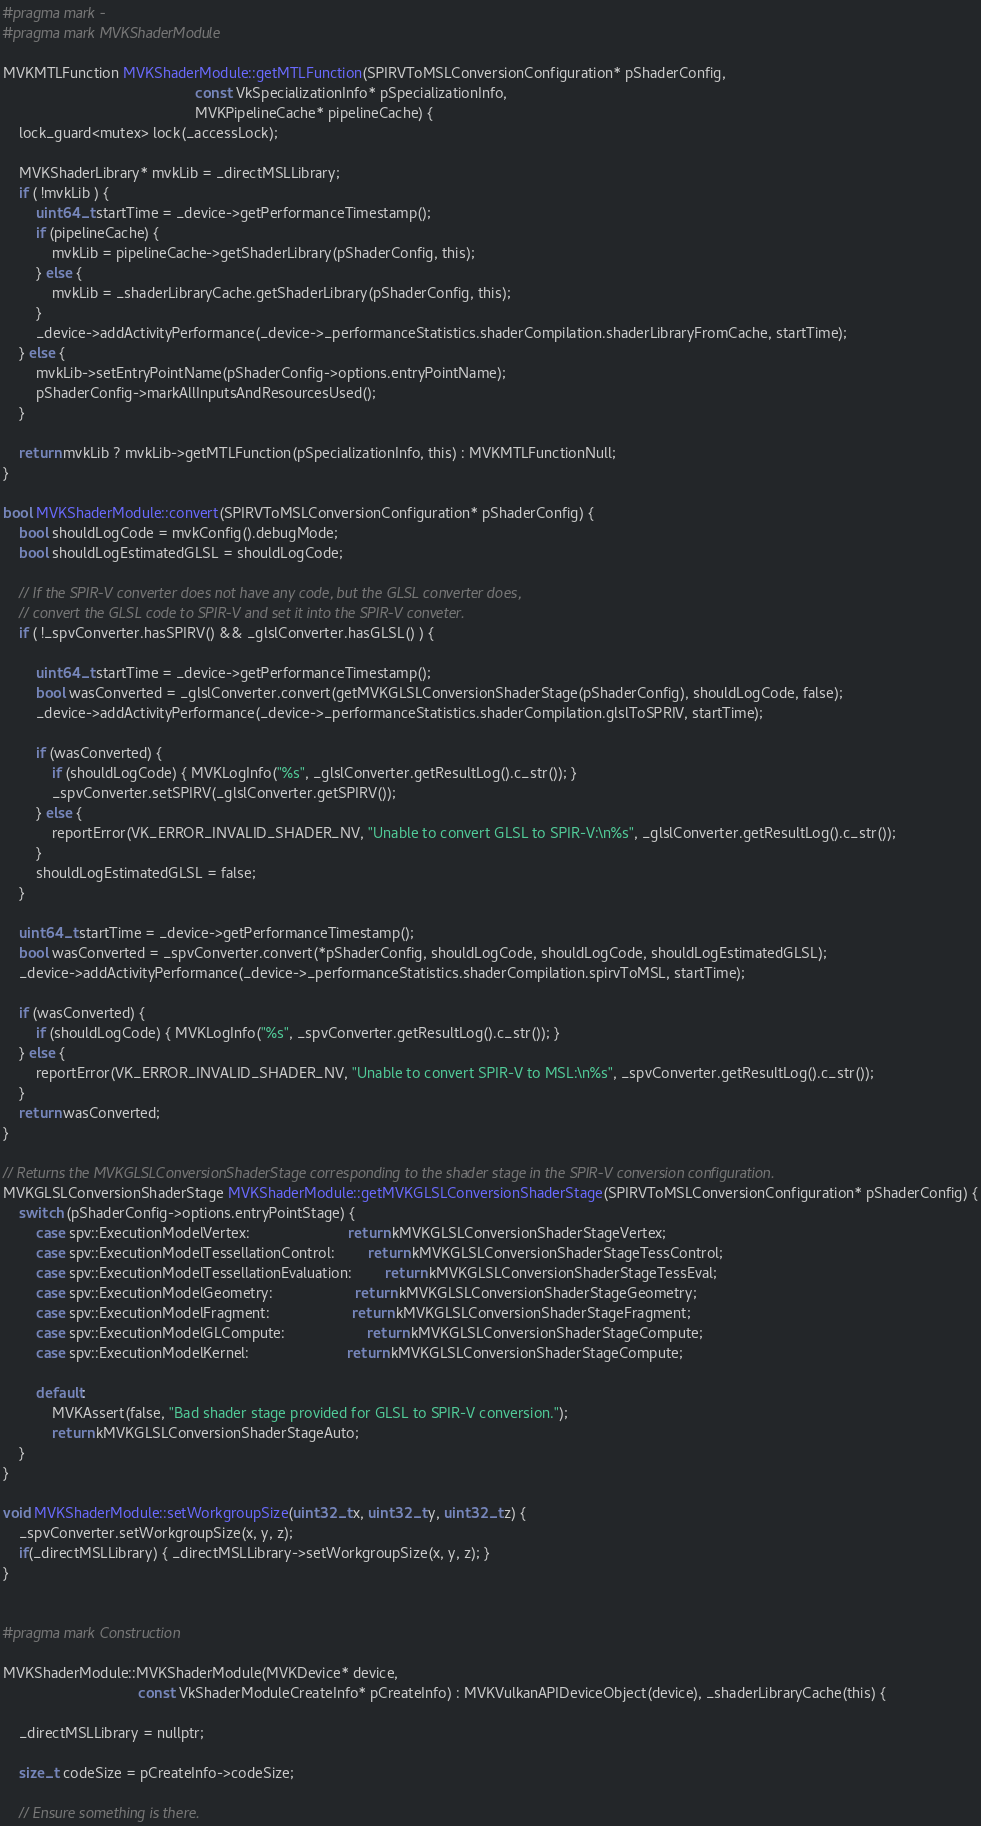<code> <loc_0><loc_0><loc_500><loc_500><_ObjectiveC_>

#pragma mark -
#pragma mark MVKShaderModule

MVKMTLFunction MVKShaderModule::getMTLFunction(SPIRVToMSLConversionConfiguration* pShaderConfig,
											   const VkSpecializationInfo* pSpecializationInfo,
											   MVKPipelineCache* pipelineCache) {
	lock_guard<mutex> lock(_accessLock);
	
	MVKShaderLibrary* mvkLib = _directMSLLibrary;
	if ( !mvkLib ) {
		uint64_t startTime = _device->getPerformanceTimestamp();
		if (pipelineCache) {
			mvkLib = pipelineCache->getShaderLibrary(pShaderConfig, this);
		} else {
			mvkLib = _shaderLibraryCache.getShaderLibrary(pShaderConfig, this);
		}
		_device->addActivityPerformance(_device->_performanceStatistics.shaderCompilation.shaderLibraryFromCache, startTime);
	} else {
		mvkLib->setEntryPointName(pShaderConfig->options.entryPointName);
		pShaderConfig->markAllInputsAndResourcesUsed();
	}

	return mvkLib ? mvkLib->getMTLFunction(pSpecializationInfo, this) : MVKMTLFunctionNull;
}

bool MVKShaderModule::convert(SPIRVToMSLConversionConfiguration* pShaderConfig) {
	bool shouldLogCode = mvkConfig().debugMode;
	bool shouldLogEstimatedGLSL = shouldLogCode;

	// If the SPIR-V converter does not have any code, but the GLSL converter does,
	// convert the GLSL code to SPIR-V and set it into the SPIR-V conveter.
	if ( !_spvConverter.hasSPIRV() && _glslConverter.hasGLSL() ) {

		uint64_t startTime = _device->getPerformanceTimestamp();
		bool wasConverted = _glslConverter.convert(getMVKGLSLConversionShaderStage(pShaderConfig), shouldLogCode, false);
		_device->addActivityPerformance(_device->_performanceStatistics.shaderCompilation.glslToSPRIV, startTime);

		if (wasConverted) {
			if (shouldLogCode) { MVKLogInfo("%s", _glslConverter.getResultLog().c_str()); }
			_spvConverter.setSPIRV(_glslConverter.getSPIRV());
		} else {
			reportError(VK_ERROR_INVALID_SHADER_NV, "Unable to convert GLSL to SPIR-V:\n%s", _glslConverter.getResultLog().c_str());
		}
		shouldLogEstimatedGLSL = false;
	}

	uint64_t startTime = _device->getPerformanceTimestamp();
	bool wasConverted = _spvConverter.convert(*pShaderConfig, shouldLogCode, shouldLogCode, shouldLogEstimatedGLSL);
	_device->addActivityPerformance(_device->_performanceStatistics.shaderCompilation.spirvToMSL, startTime);

	if (wasConverted) {
		if (shouldLogCode) { MVKLogInfo("%s", _spvConverter.getResultLog().c_str()); }
	} else {
		reportError(VK_ERROR_INVALID_SHADER_NV, "Unable to convert SPIR-V to MSL:\n%s", _spvConverter.getResultLog().c_str());
	}
	return wasConverted;
}

// Returns the MVKGLSLConversionShaderStage corresponding to the shader stage in the SPIR-V conversion configuration.
MVKGLSLConversionShaderStage MVKShaderModule::getMVKGLSLConversionShaderStage(SPIRVToMSLConversionConfiguration* pShaderConfig) {
	switch (pShaderConfig->options.entryPointStage) {
		case spv::ExecutionModelVertex:						return kMVKGLSLConversionShaderStageVertex;
		case spv::ExecutionModelTessellationControl:		return kMVKGLSLConversionShaderStageTessControl;
		case spv::ExecutionModelTessellationEvaluation:		return kMVKGLSLConversionShaderStageTessEval;
		case spv::ExecutionModelGeometry:					return kMVKGLSLConversionShaderStageGeometry;
		case spv::ExecutionModelFragment:					return kMVKGLSLConversionShaderStageFragment;
		case spv::ExecutionModelGLCompute:					return kMVKGLSLConversionShaderStageCompute;
		case spv::ExecutionModelKernel:						return kMVKGLSLConversionShaderStageCompute;

		default:
			MVKAssert(false, "Bad shader stage provided for GLSL to SPIR-V conversion.");
			return kMVKGLSLConversionShaderStageAuto;
	}
}

void MVKShaderModule::setWorkgroupSize(uint32_t x, uint32_t y, uint32_t z) {
	_spvConverter.setWorkgroupSize(x, y, z);
	if(_directMSLLibrary) { _directMSLLibrary->setWorkgroupSize(x, y, z); }
}


#pragma mark Construction

MVKShaderModule::MVKShaderModule(MVKDevice* device,
								 const VkShaderModuleCreateInfo* pCreateInfo) : MVKVulkanAPIDeviceObject(device), _shaderLibraryCache(this) {

	_directMSLLibrary = nullptr;

	size_t codeSize = pCreateInfo->codeSize;

    // Ensure something is there.</code> 